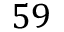Convert formula to latex. <formula><loc_0><loc_0><loc_500><loc_500>5 9</formula> 